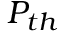Convert formula to latex. <formula><loc_0><loc_0><loc_500><loc_500>P _ { t h }</formula> 